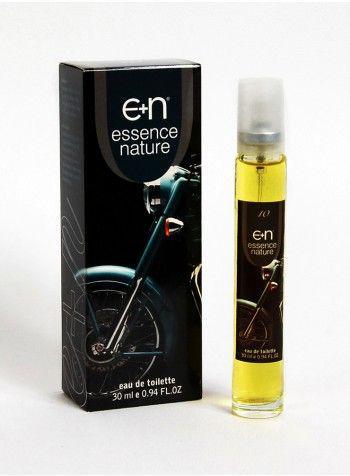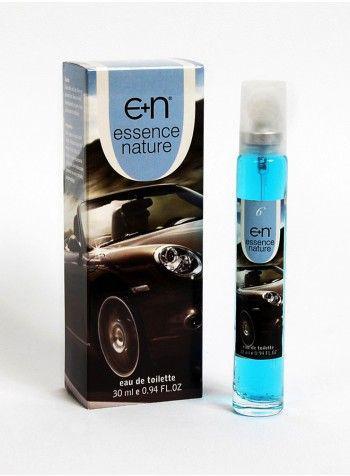The first image is the image on the left, the second image is the image on the right. For the images displayed, is the sentence "The right image contains a slim container with blue liquid inside it." factually correct? Answer yes or no. Yes. The first image is the image on the left, the second image is the image on the right. Given the left and right images, does the statement "Each image shows one upright fragrance bottle to the right of its box, and one of the images features a box with a sports car on its front." hold true? Answer yes or no. Yes. 